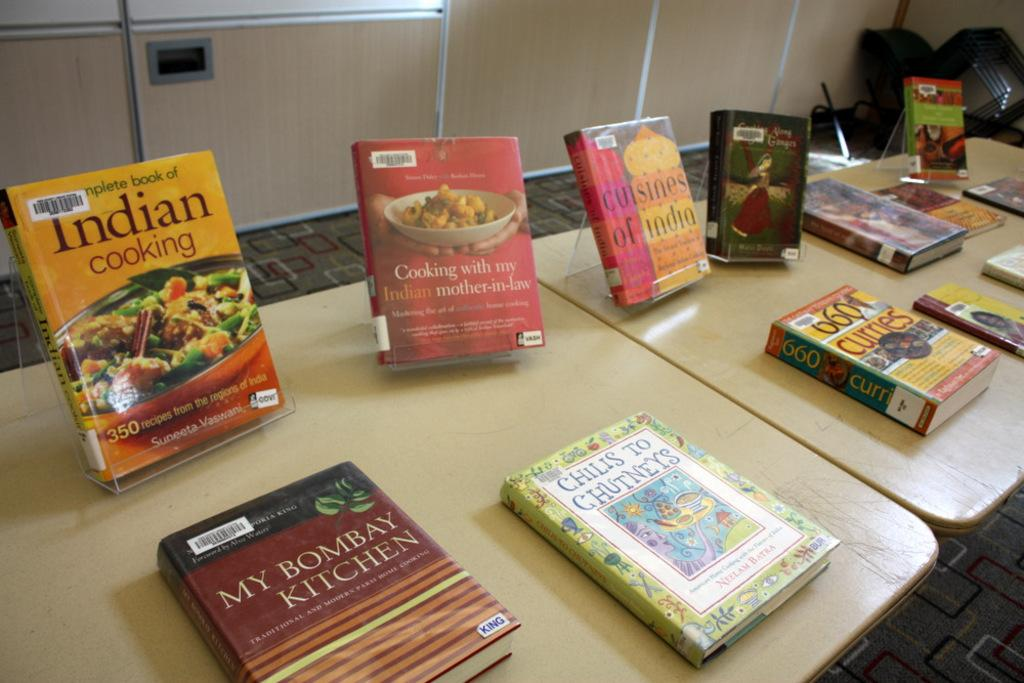What objects are on the table in the image? There are books on the table in the image. Can you describe the appearance of the books? The books are in multiple colors. What is the color of the table in the image? The table is cream-colored. What type of material can be seen in the background of the image? There is a wooden wall in the background of the image. How many oranges are hanging from the wooden wall in the image? There are no oranges present in the image; it only features books on a table and a wooden wall in the background. 